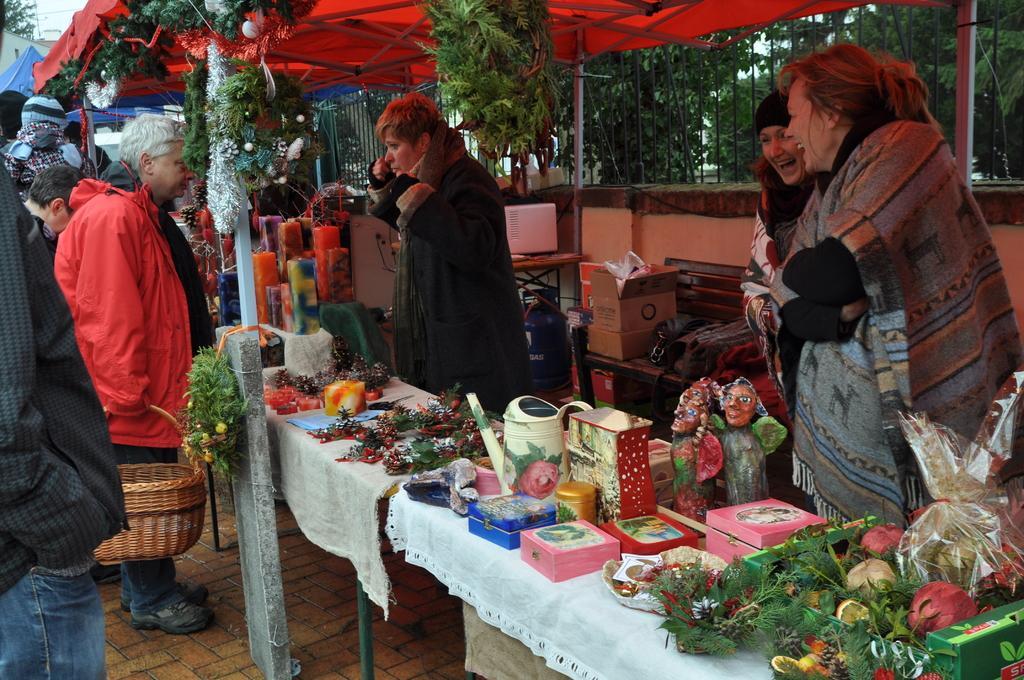How would you summarize this image in a sentence or two? In this image there are a group of people standing, and one person is holding a basket and in the center there is a table. And on the table there are some boxes, plants, toys, jug, and some other objects. And in the background there are some tables, boxes and some other objects. And at the top there is a railing and some trees are there in the background and there is a wall and also there are some decorations and buildings. At the bottom there is a walkway. 